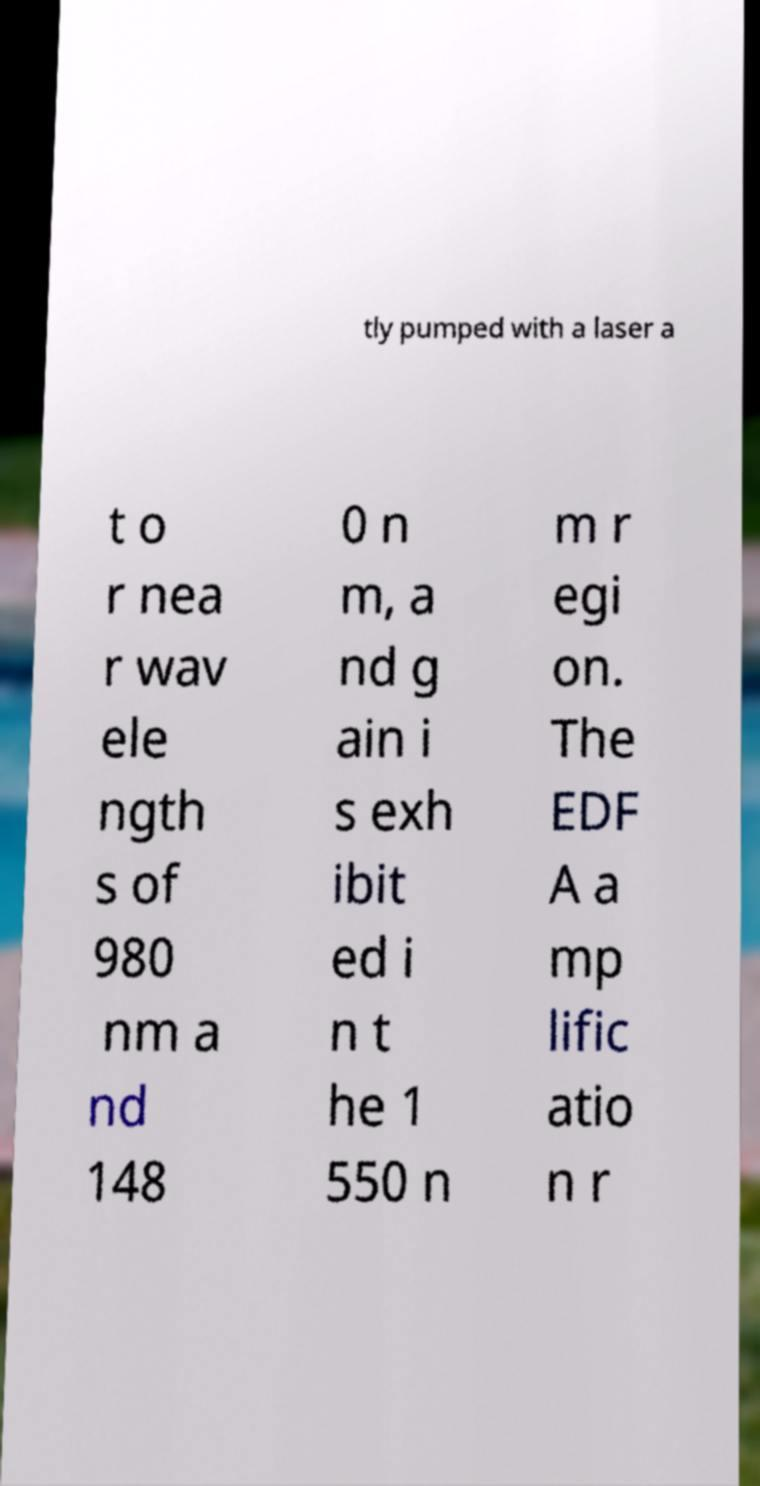Please identify and transcribe the text found in this image. tly pumped with a laser a t o r nea r wav ele ngth s of 980 nm a nd 148 0 n m, a nd g ain i s exh ibit ed i n t he 1 550 n m r egi on. The EDF A a mp lific atio n r 